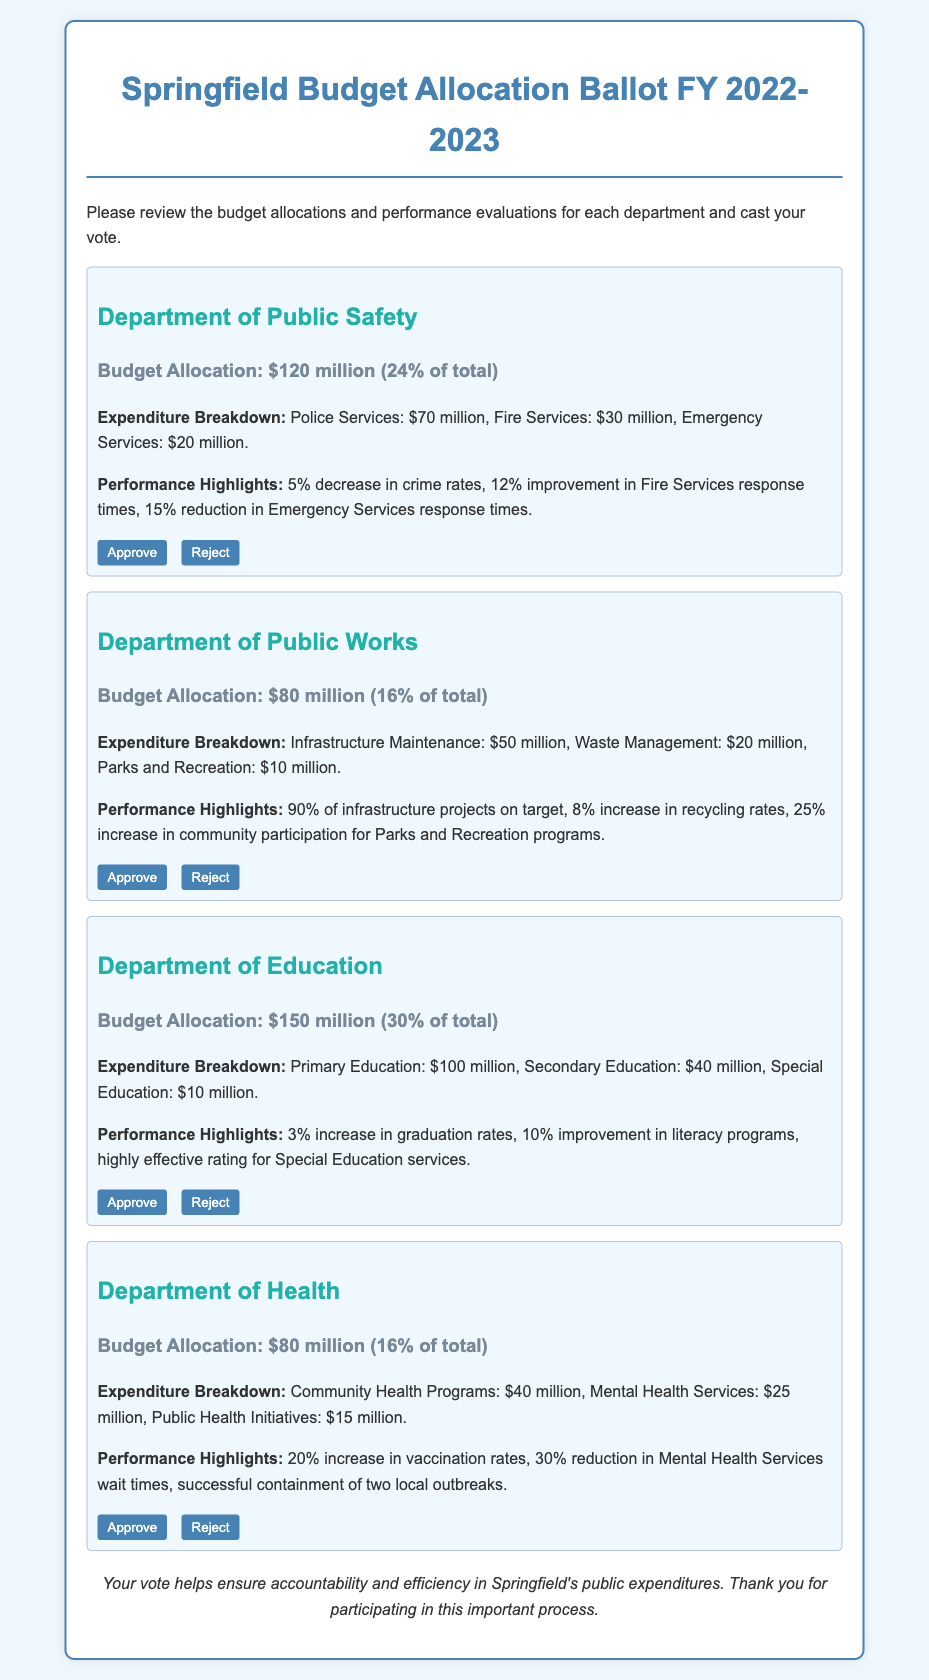What is the budget allocation for the Department of Health? The budget allocation for the Department of Health is provided in the document, which is $80 million.
Answer: $80 million What percentage of the total budget does the Department of Education receive? The document states that the Department of Education's budget allocation is 30% of the total.
Answer: 30% Which department allocated the highest amount for Primary Education? From the document, the Department of Education allocated the highest amount for Primary Education, which is $100 million.
Answer: $100 million What was the percentage increase in graduation rates for the Department of Education? The document highlights a 3% increase in graduation rates for the Department of Education.
Answer: 3% How much money is allocated to Fire Services in the Department of Public Safety? According to the document, Fire Services in the Department of Public Safety has an allocation of $30 million.
Answer: $30 million What percentage of infrastructure projects is reported to be on target by the Department of Public Works? The performance highlights section states that 90% of infrastructure projects are on target by the Department of Public Works.
Answer: 90% What is the performance improvement in Mental Health Services wait times reported by the Department of Health? The document reports a 30% reduction in Mental Health Services wait times by the Department of Health.
Answer: 30% Which department provides the highest number of votes for approval? The document includes buttons for voting but does not indicate actual votes yet; however, the Department of Education has the highest budget, which may suggest it attracts more approval votes.
Answer: Department of Education What does the conclusion of the ballot emphasize regarding public expenditures? The conclusion emphasizes ensuring accountability and efficiency in Springfield's public expenditures.
Answer: Accountability and efficiency 